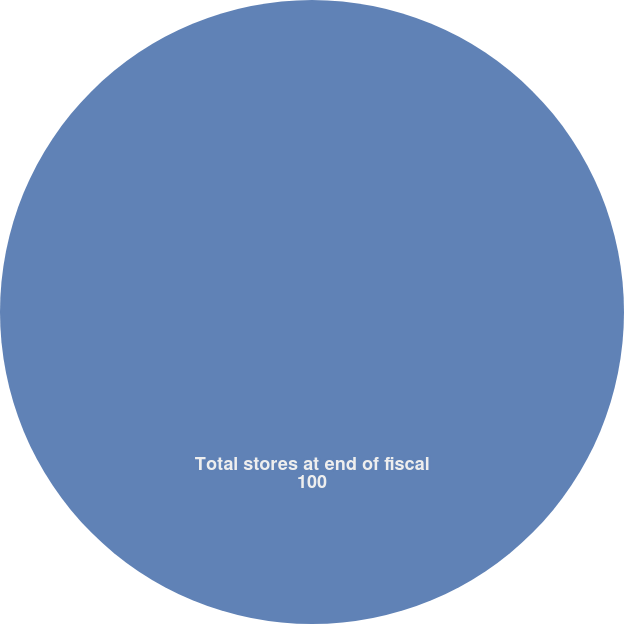<chart> <loc_0><loc_0><loc_500><loc_500><pie_chart><fcel>Total stores at end of fiscal<nl><fcel>100.0%<nl></chart> 